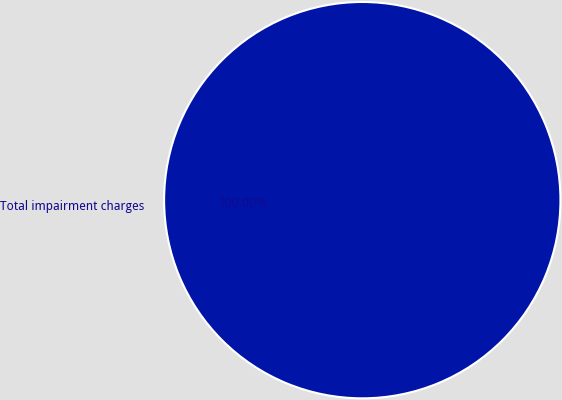<chart> <loc_0><loc_0><loc_500><loc_500><pie_chart><fcel>Total impairment charges<nl><fcel>100.0%<nl></chart> 